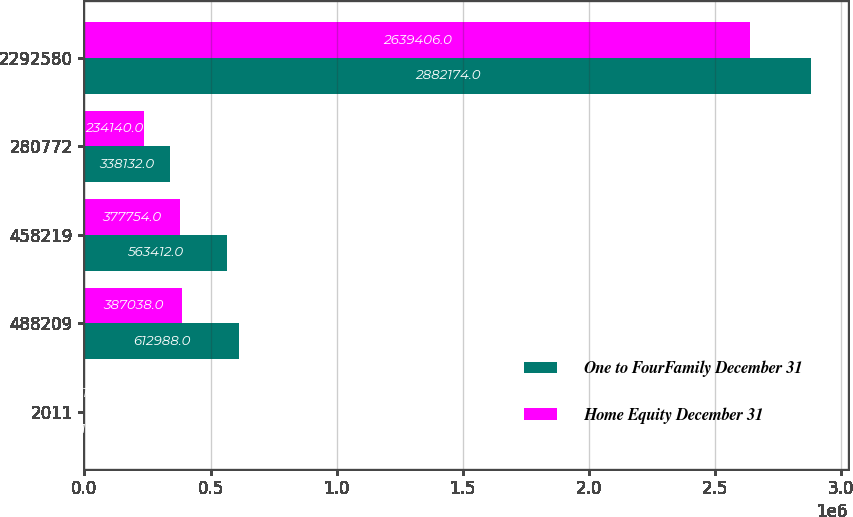<chart> <loc_0><loc_0><loc_500><loc_500><stacked_bar_chart><ecel><fcel>2011<fcel>488209<fcel>458219<fcel>280772<fcel>2292580<nl><fcel>One to FourFamily December 31<fcel>2010<fcel>612988<fcel>563412<fcel>338132<fcel>2.88217e+06<nl><fcel>Home Equity December 31<fcel>2011<fcel>387038<fcel>377754<fcel>234140<fcel>2.63941e+06<nl></chart> 